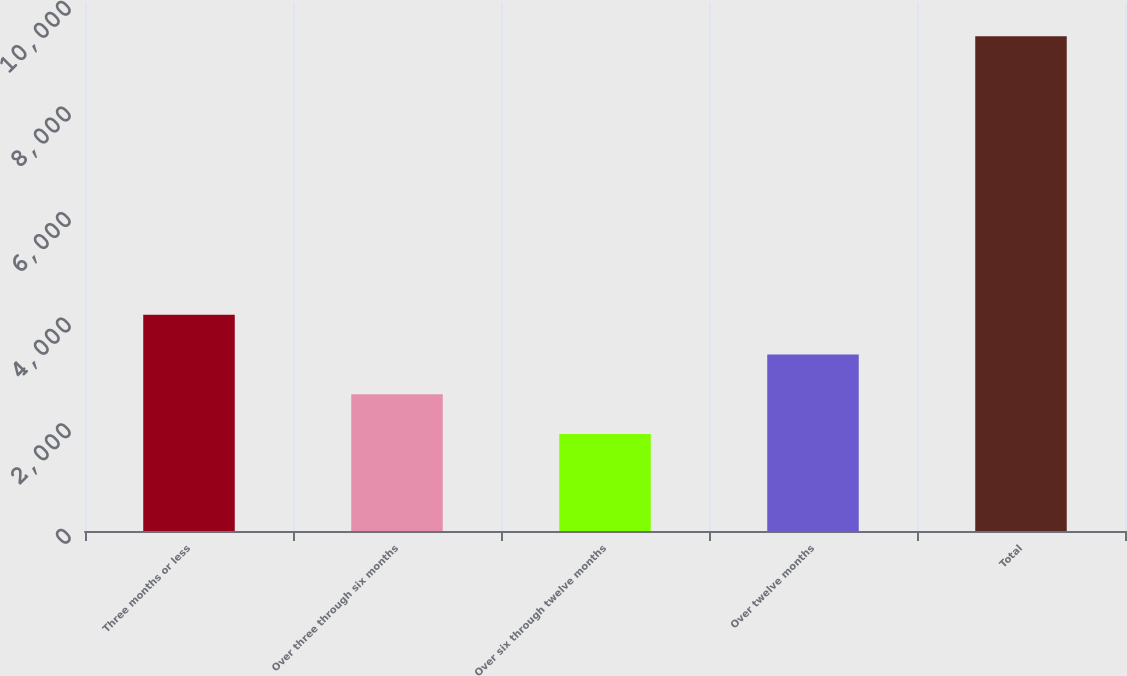Convert chart to OTSL. <chart><loc_0><loc_0><loc_500><loc_500><bar_chart><fcel>Three months or less<fcel>Over three through six months<fcel>Over six through twelve months<fcel>Over twelve months<fcel>Total<nl><fcel>4095.5<fcel>2588.5<fcel>1835<fcel>3342<fcel>9370<nl></chart> 